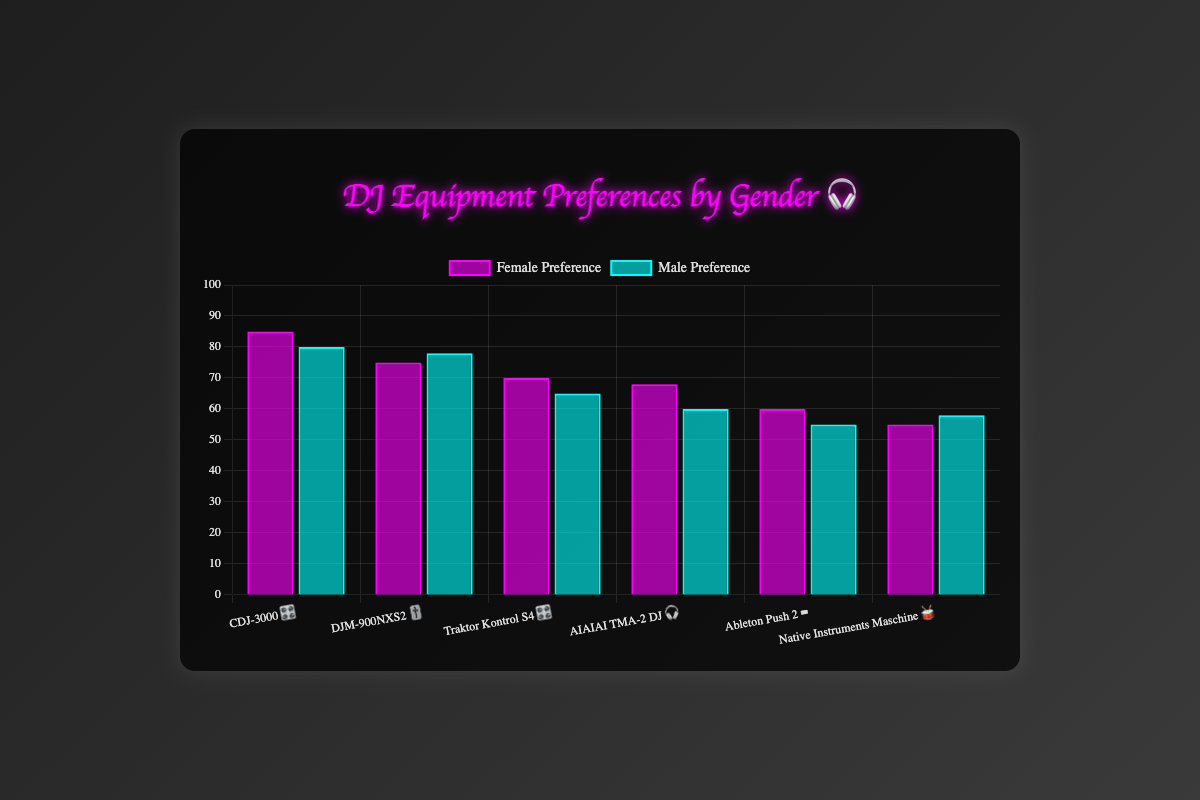Which item has the highest preference among female DJs? Look for the item with the highest bar in the "Female Preference" category. CDJ-3000 🎛️ has a height of 85, which is the highest.
Answer: CDJ-3000 🎛️ Which equipment has the largest difference in preference between female and male DJs? Calculate the absolute difference in preference values for each item. The largest difference is between AIAIAI TMA-2 DJ 🎧 with a difference of
Answer: AIAIAI TMA-2 DJ 🎧 (8) What is the combined preference for the Native Instruments Maschine 🥁 between both genders? Add the female and male preferences for Native Instruments Maschine 🥁. That is 55 + 58 = 113.
Answer: 113 Which gender shows a higher preference for the Traktor Kontrol S4 🎛️? Compare the heights of the bars for Traktor Kontrol S4 🎛️. Female preference is 70 while male preference is 65.
Answer: Female What are the labels of the equipment with the closest preference values between genders? Find the items where the female and male bars are closest in height. Ableton Push 2 ⌨️ has female preference 60 and male preference 55, and DJM-900NXS2 🎚️ has female preference 75 and male preference 78.
Answer: Ableton Push 2 ⌨️, DJM-900NXS2 🎚️ What is the average preference for female DJs across all equipment? Sum the female preference values (85 + 75 + 70 + 68 + 60 + 55) and then divide by the number of items (6). (85 + 75 + 70 + 68 + 60 + 55) / 6 = 68.83.
Answer: 68.83 Which equipment preferences show that males prefer slightly more than females? Identify items where the male preference is slightly higher than female preference. DJM-900NXS2 🎚️ and Native Instruments Maschine 🥁 have higher male preferences by 3 and 3, respectively.
Answer: DJM-900NXS2 🎚️, Native Instruments Maschine 🥁 Which item shows the least overall popularity when combined across both genders? Find the equipment with the smallest sum of female and male preferences. Ableton Push 2 ⌨️ has a combined preference of 115 (60+55).
Answer: Ableton Push 2 ⌨️ How do male preferences for AIAIAI TMA-2 DJ 🎧 compare to female preferences for the same equipment? Compare the values of male and female preferences for AIAIAI TMA-2 DJ 🎧. Female: 68, Male: 60.
Answer: Female preference is higher (68 vs. 60) What is the median preference value for female DJs? Arrange the female preference values in ascending order (55, 60, 68, 70, 75, 85). With 6 data points, the median is the average of the 3rd and 4th values. (68 + 70) / 2 = 69.
Answer: 69 